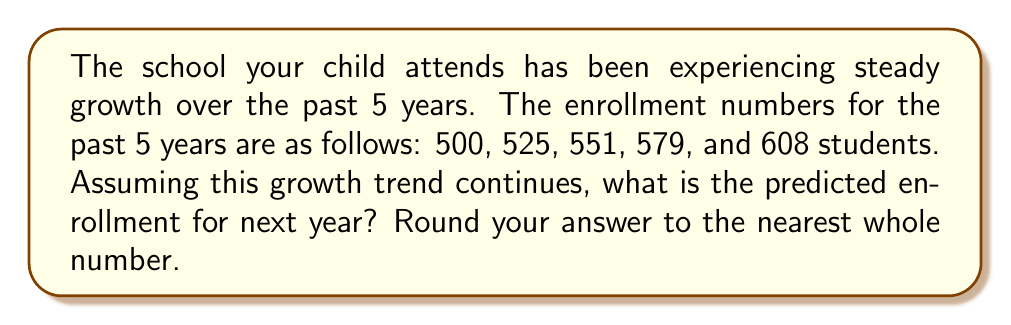Help me with this question. To predict the future enrollment, we need to analyze the growth trend. Let's follow these steps:

1. Calculate the year-over-year growth rate:
   Year 1 to 2: $(525 - 500) / 500 = 0.05$ or 5%
   Year 2 to 3: $(551 - 525) / 525 = 0.0495$ or 4.95%
   Year 3 to 4: $(579 - 551) / 551 = 0.0508$ or 5.08%
   Year 4 to 5: $(608 - 579) / 579 = 0.0501$ or 5.01%

2. Calculate the average growth rate:
   $\text{Average growth rate} = \frac{0.05 + 0.0495 + 0.0508 + 0.0501}{4} = 0.0501$ or 5.01%

3. Use the average growth rate to predict next year's enrollment:
   $\text{Predicted enrollment} = 608 \times (1 + 0.0501) = 608 \times 1.0501 = 638.4608$

4. Round to the nearest whole number:
   $638.4608 \approx 638$ students
Answer: 638 students 